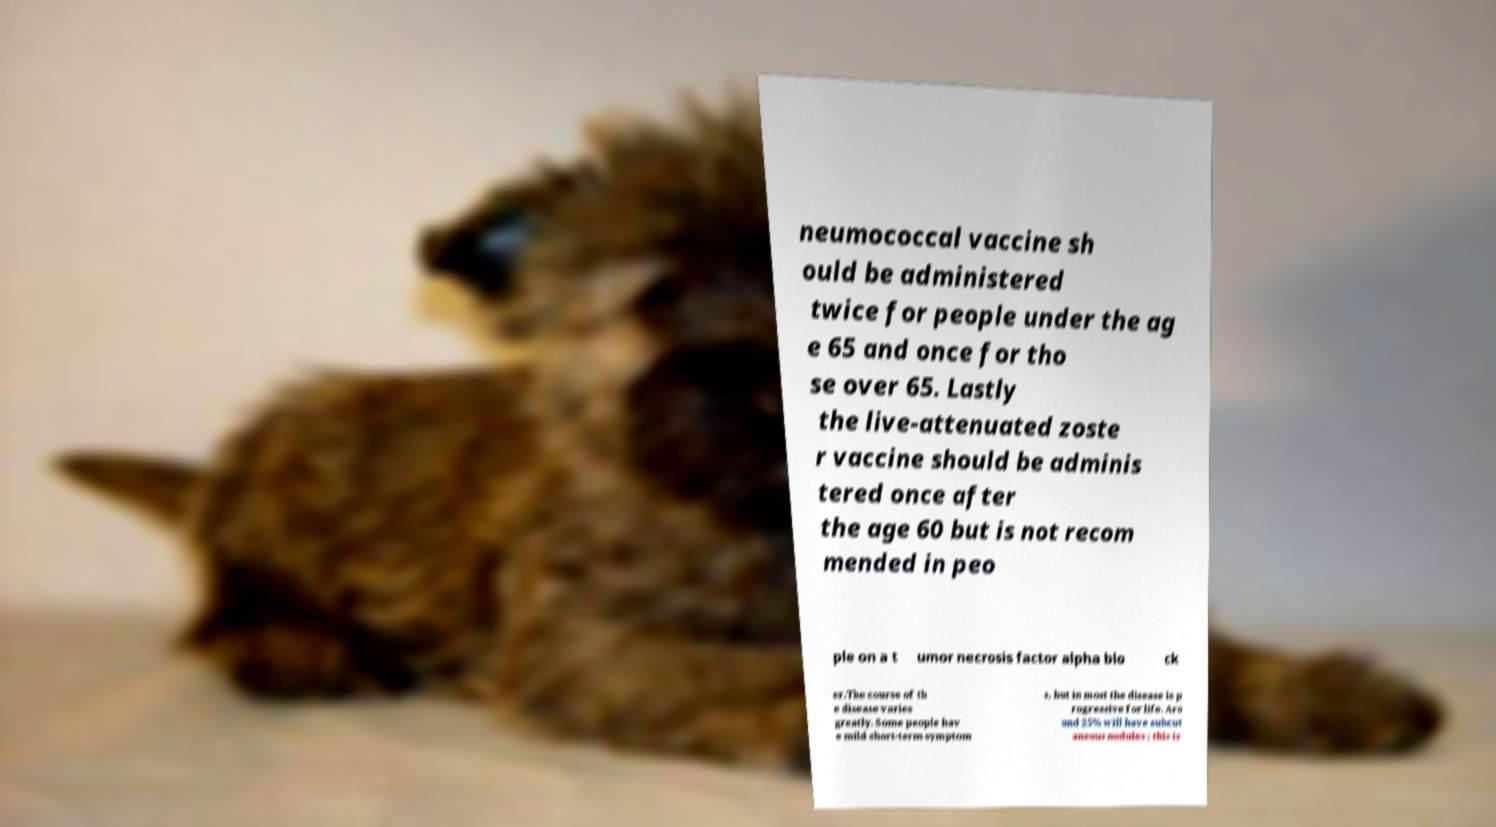Can you accurately transcribe the text from the provided image for me? neumococcal vaccine sh ould be administered twice for people under the ag e 65 and once for tho se over 65. Lastly the live-attenuated zoste r vaccine should be adminis tered once after the age 60 but is not recom mended in peo ple on a t umor necrosis factor alpha blo ck er.The course of th e disease varies greatly. Some people hav e mild short-term symptom s, but in most the disease is p rogressive for life. Aro und 25% will have subcut aneous nodules ; this is 